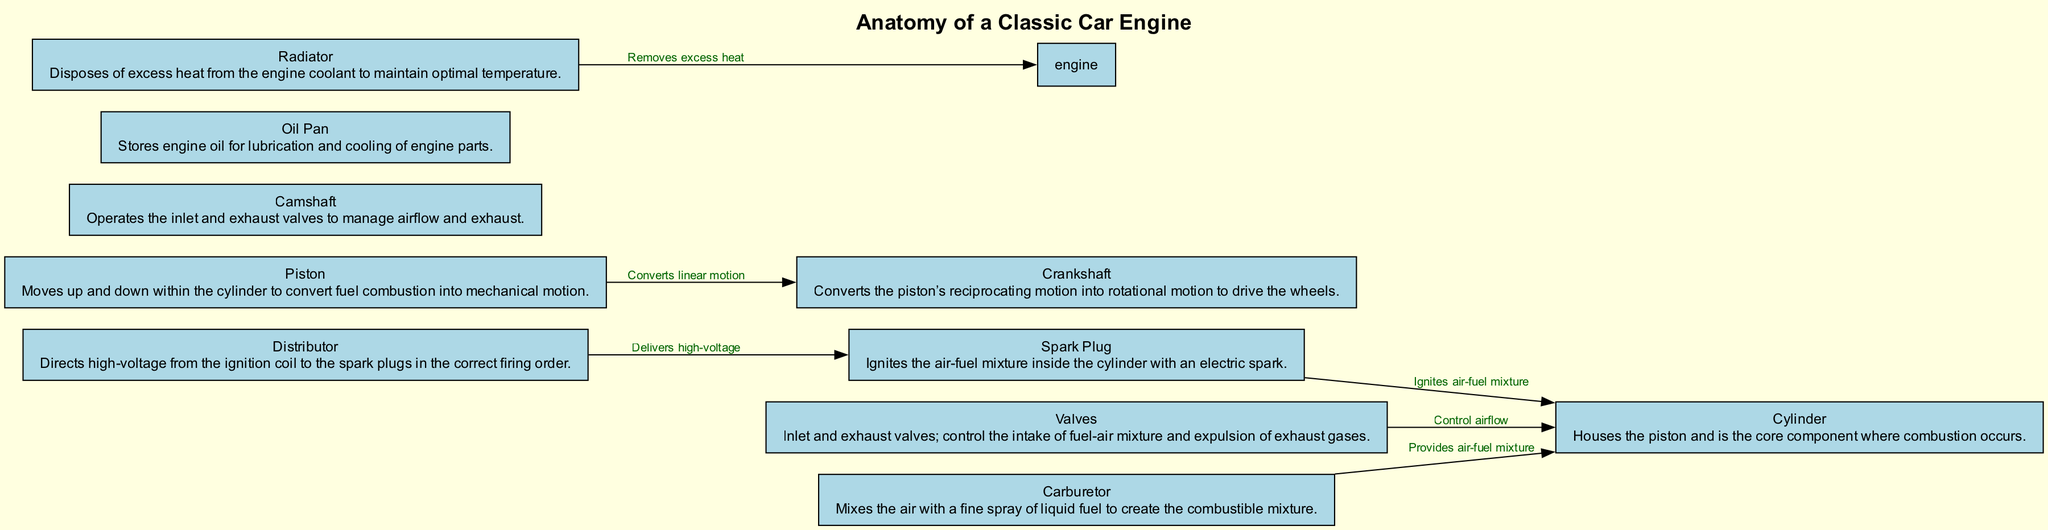What is the core component where combustion occurs? The diagram identifies the "Cylinder" as the component that houses the piston and is where combustion takes place.
Answer: Cylinder How many nodes are labeled in the diagram? By counting the nodes mentioned in the data, there are 10 distinct labeled parts of the engine represented in the diagram.
Answer: 10 What component ignites the air-fuel mixture? The "Spark Plug" is specifically labeled in the diagram as the part that ignites the air-fuel mixture inside the cylinder.
Answer: Spark Plug What does the crankshaft convert? The diagram indicates that the crankshaft converts the linear motion of the piston into rotational motion to drive the wheels.
Answer: Linear motion Which component delivers high-voltage to the spark plugs? The diagram shows that the "Distributor" is responsible for directing high-voltage from the ignition coil to the spark plugs in the correct firing order.
Answer: Distributor What is the function of the radiator in the engine? The radiator's function is to remove excess heat from the engine coolant, shown in the diagram to maintain optimal temperature within the engine.
Answer: Removes excess heat How does air enter the cylinder? The diagram indicates that the inlet valves control the intake of the fuel-air mixture, allowing air to enter the cylinder.
Answer: Inlet valves Which part of the engine is responsible for lubrication and cooling? The "Oil Pan" is depicted in the diagram as the component that stores engine oil for lubrication and cooling of the engine parts.
Answer: Oil Pan What does the camshaft operate? According to the diagram, the camshaft operates both the inlet and exhaust valves, managing airflow and exhaust processes in the engine.
Answer: Inlet and exhaust valves 